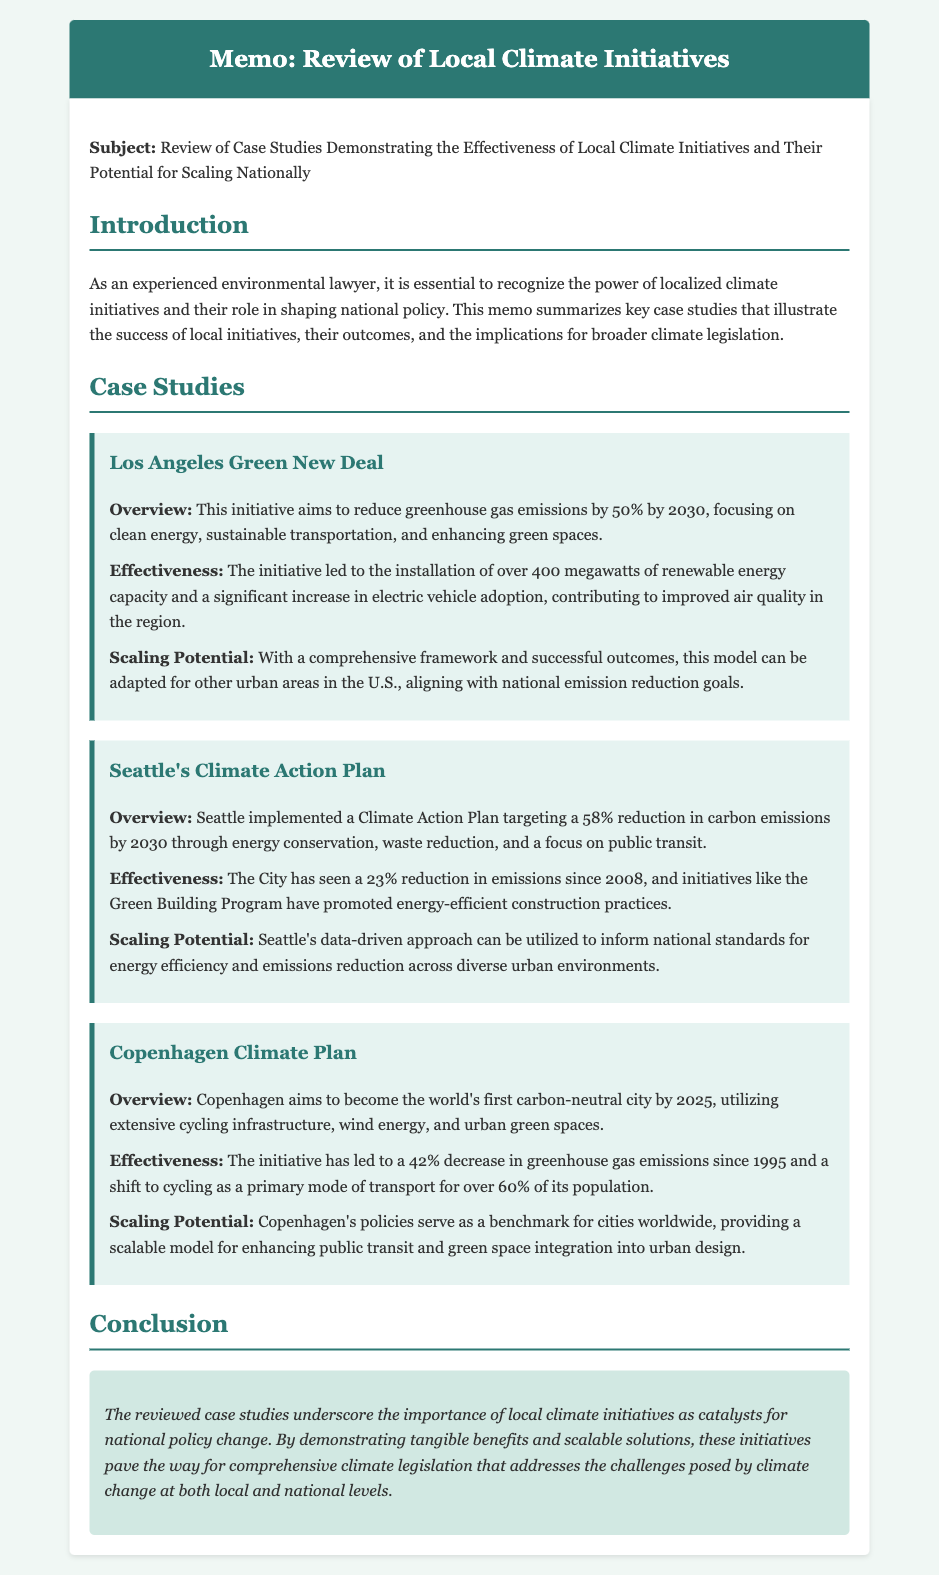What is the main subject of the memo? The subject of the memo is explicitly stated in the introduction as a review of local climate initiatives and their scaling potential.
Answer: Review of Case Studies Demonstrating the Effectiveness of Local Climate Initiatives and Their Potential for Scaling Nationally What percentage reduction in greenhouse gas emissions does the Los Angeles Green New Deal aim for by 2030? The document specifies that the Los Angeles Green New Deal targets a 50% reduction in greenhouse gas emissions by 2030.
Answer: 50% What is the target carbon emission reduction percentage for Seattle's Climate Action Plan by 2030? The memo outlines that Seattle's Climate Action Plan aims for a 58% reduction in carbon emissions by 2030.
Answer: 58% Since what year has Seattle seen a 23% reduction in emissions? The document notes that the reduction has occurred since 2008.
Answer: 2008 What is the primary transportation mode for over 60% of Copenhagen's population? The document states that cycling is the primary mode of transport for over 60% of Copenhagen's population.
Answer: Cycling What year does Copenhagen aim to achieve carbon neutrality by? The document clearly indicates that Copenhagen aims to become carbon-neutral by the year 2025.
Answer: 2025 Which case study emphasizes a data-driven approach for scaling potential? Seattle's Climate Action Plan is highlighted in the memo for utilizing a data-driven approach.
Answer: Seattle's Climate Action Plan What type of initiatives are highlighted in the memo as catalysts for national policy change? The memo emphasizes local climate initiatives as key catalysts for broader national policy changes.
Answer: Local climate initiatives 